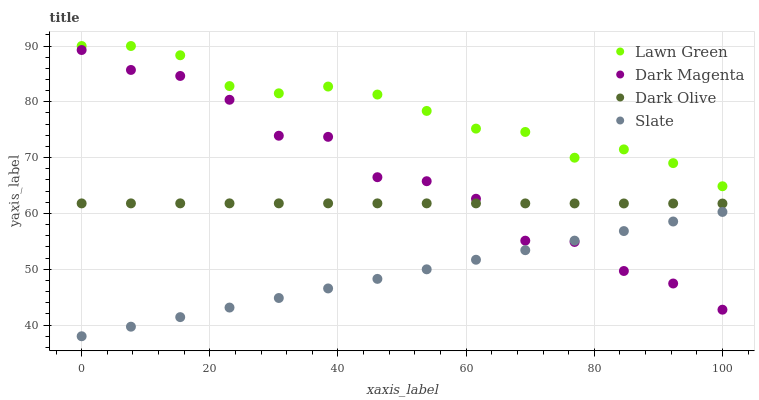Does Slate have the minimum area under the curve?
Answer yes or no. Yes. Does Lawn Green have the maximum area under the curve?
Answer yes or no. Yes. Does Dark Olive have the minimum area under the curve?
Answer yes or no. No. Does Dark Olive have the maximum area under the curve?
Answer yes or no. No. Is Slate the smoothest?
Answer yes or no. Yes. Is Dark Magenta the roughest?
Answer yes or no. Yes. Is Dark Olive the smoothest?
Answer yes or no. No. Is Dark Olive the roughest?
Answer yes or no. No. Does Slate have the lowest value?
Answer yes or no. Yes. Does Dark Olive have the lowest value?
Answer yes or no. No. Does Lawn Green have the highest value?
Answer yes or no. Yes. Does Dark Olive have the highest value?
Answer yes or no. No. Is Dark Magenta less than Lawn Green?
Answer yes or no. Yes. Is Dark Olive greater than Slate?
Answer yes or no. Yes. Does Dark Olive intersect Dark Magenta?
Answer yes or no. Yes. Is Dark Olive less than Dark Magenta?
Answer yes or no. No. Is Dark Olive greater than Dark Magenta?
Answer yes or no. No. Does Dark Magenta intersect Lawn Green?
Answer yes or no. No. 